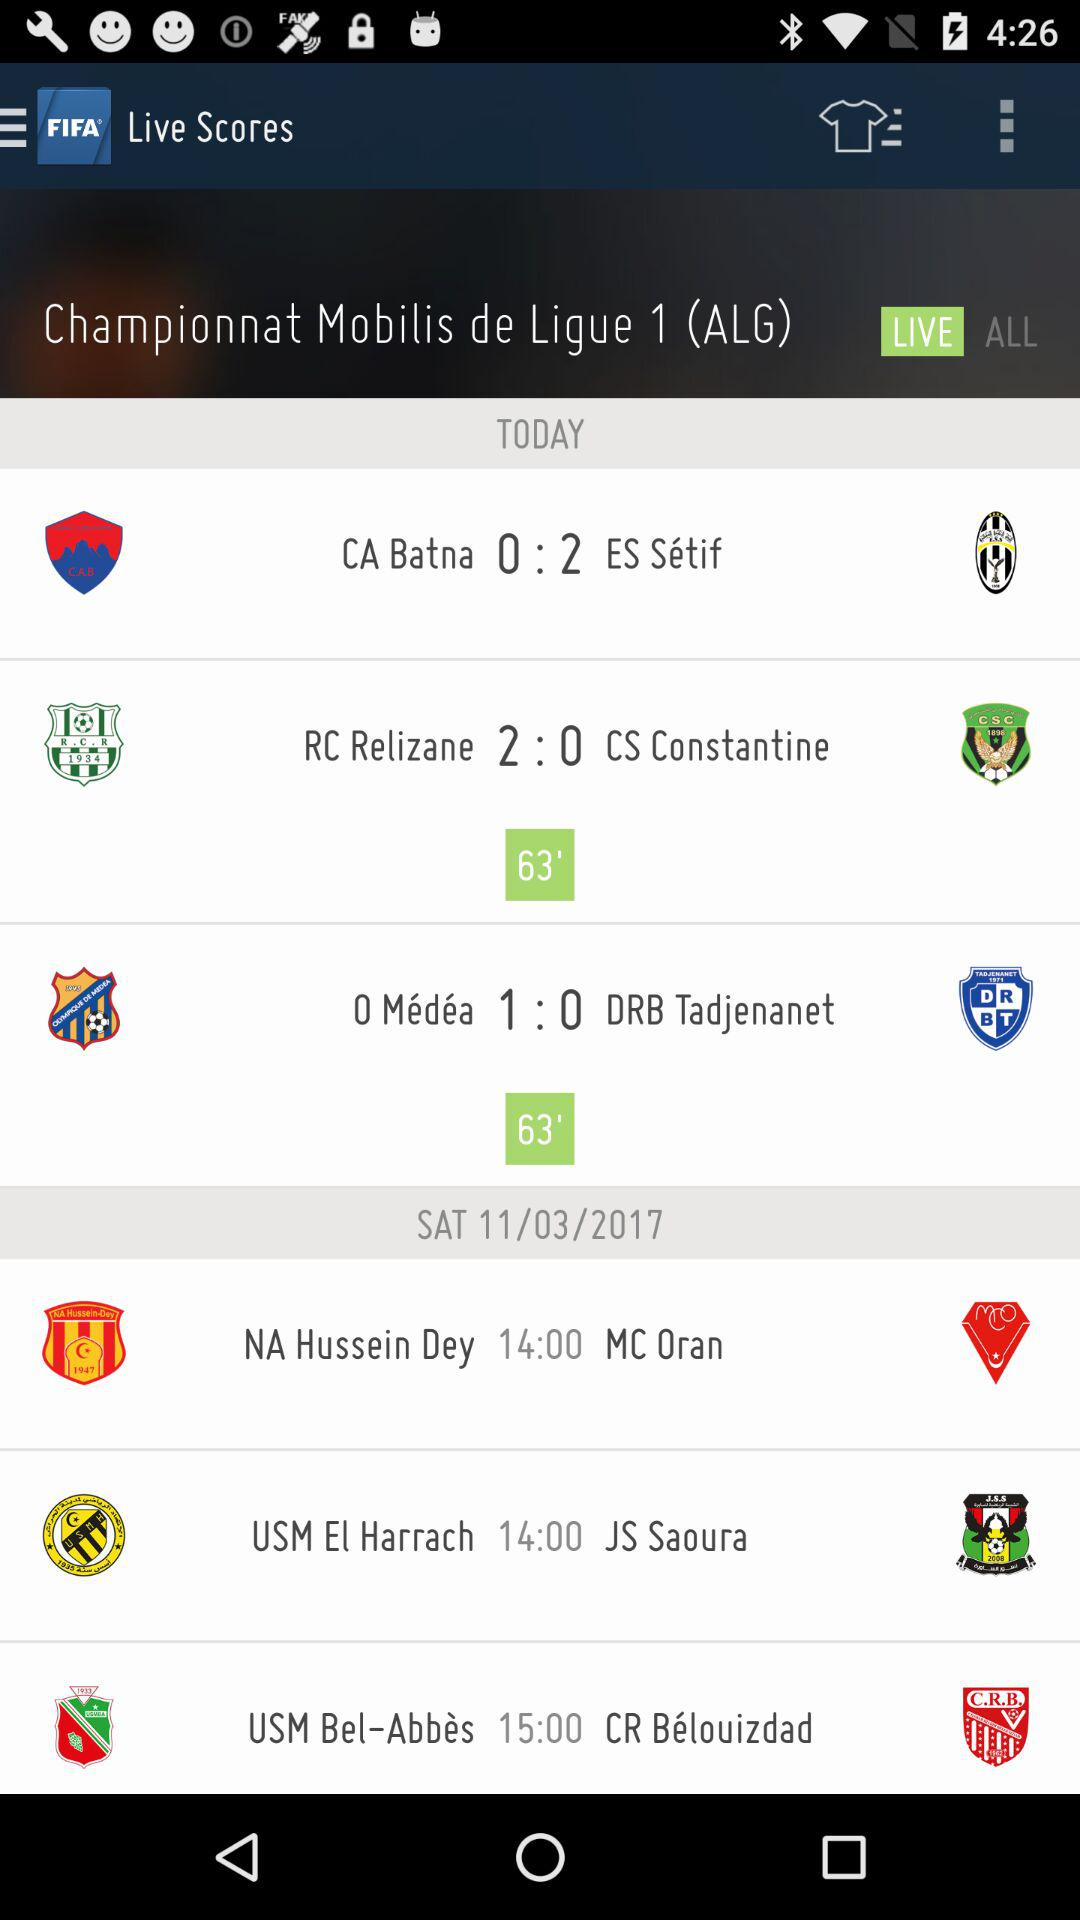How many matches have a score of 0:2?
Answer the question using a single word or phrase. 1 